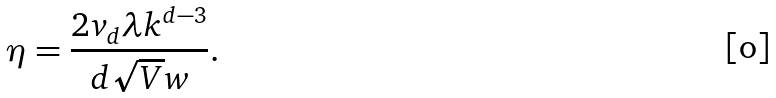Convert formula to latex. <formula><loc_0><loc_0><loc_500><loc_500>\eta = \frac { 2 v _ { d } \lambda k ^ { d - 3 } } { d \sqrt { V } w } .</formula> 